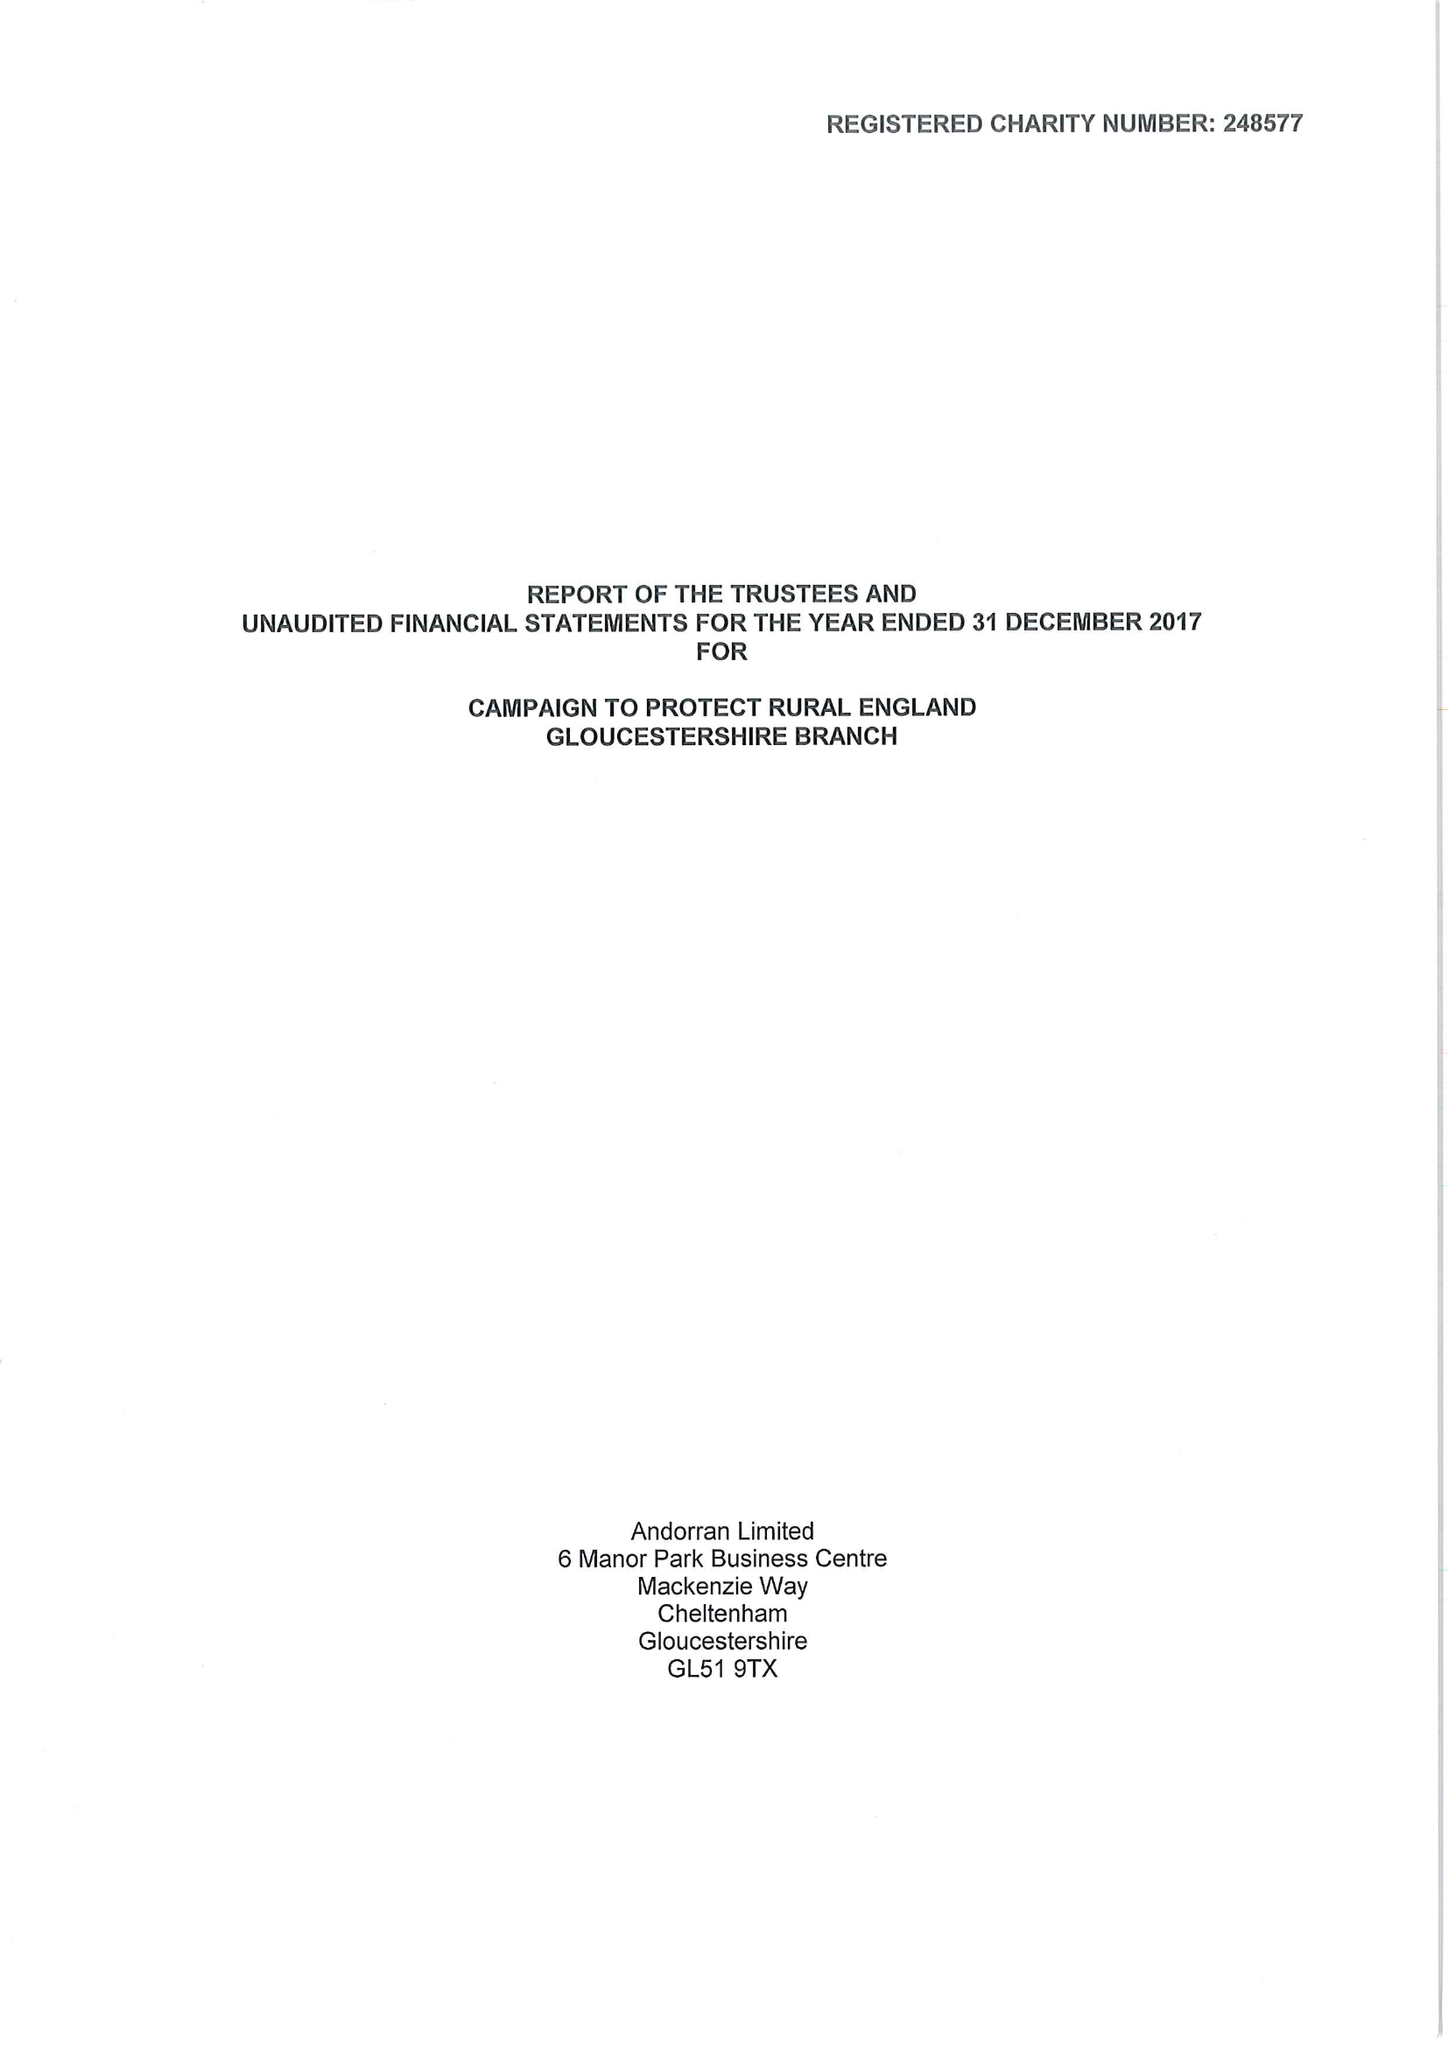What is the value for the spending_annually_in_british_pounds?
Answer the question using a single word or phrase. 53848.00 